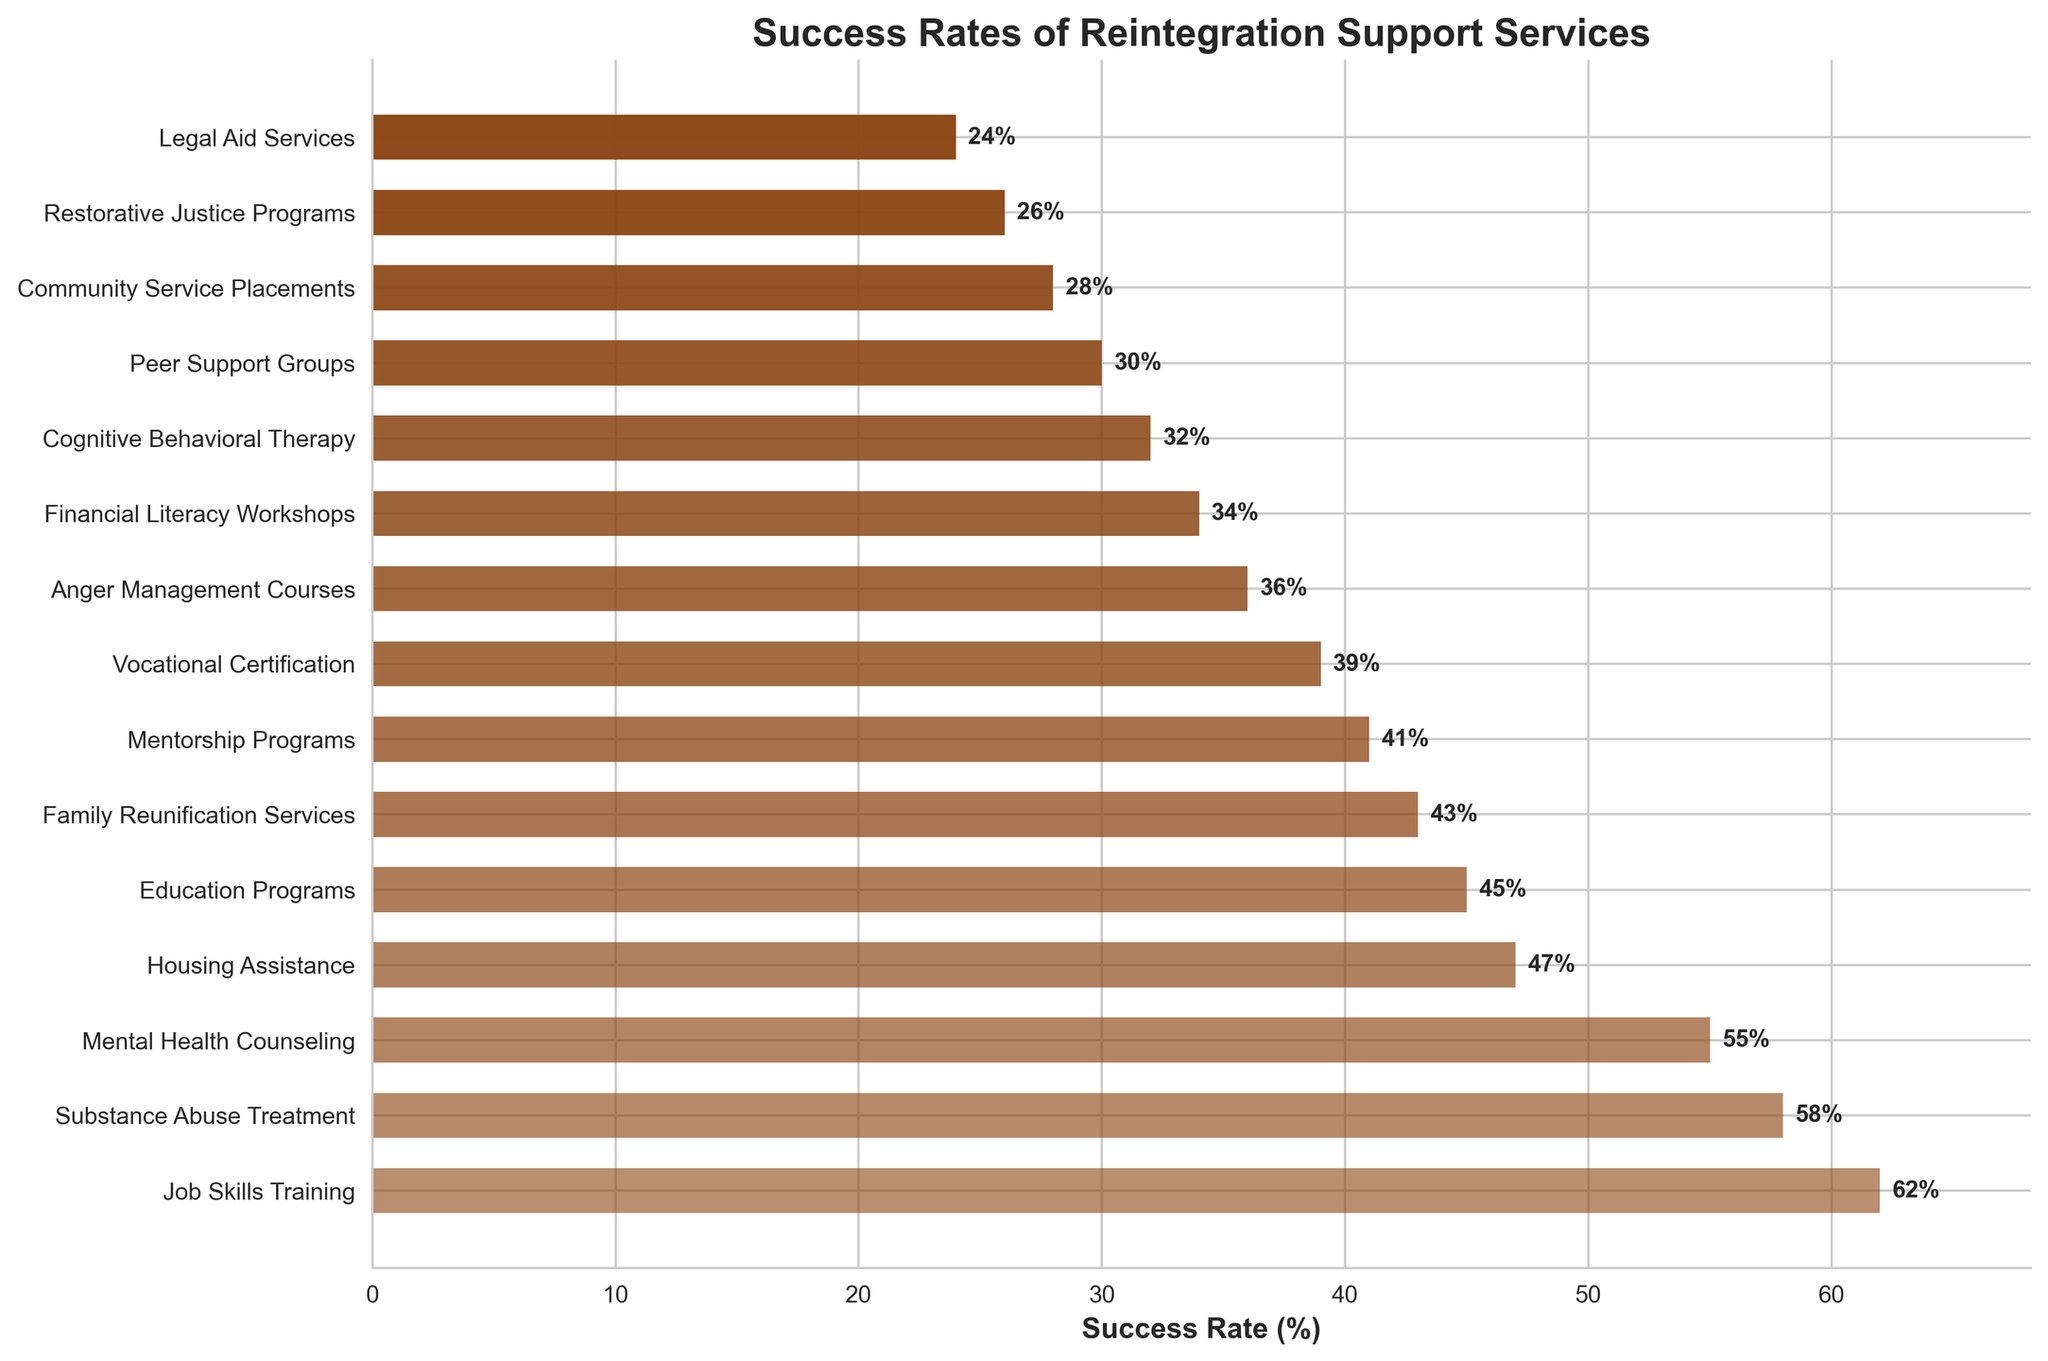Which reintegration support service has the highest success rate? To find the service with the highest success rate, look for the bar that is the longest in the plotted figure. The label associated with this bar represents the service with the highest success rate.
Answer: Job Skills Training Which reintegration support service has the lowest success rate? To identify the service with the lowest success rate, locate the shortest bar on the plot. The label next to this bar indicates the service with the lowest success rate.
Answer: Legal Aid Services How much higher is the success rate of 'Job Skills Training' compared to 'Financial Literacy Workshops'? Look at the bars corresponding to both 'Job Skills Training' and 'Financial Literacy Workshops'. The success rate for 'Job Skills Training' is 62%, and for 'Financial Literacy Workshops', it is 34%. Calculate the difference by subtracting 34% from 62%.
Answer: 28% What is the average success rate of the top five reintegration support services? Identify the top five services in terms of success rates: 'Job Skills Training' (62%), 'Substance Abuse Treatment' (58%), 'Mental Health Counseling' (55%), 'Housing Assistance' (47%), and 'Education Programs' (45%). Sum these rates and divide by 5. (62 + 58 + 55 + 47 + 45) / 5 = 267 / 5 = 53.4.
Answer: 53.4% How do the success rates of 'Peer Support Groups' and 'Restorative Justice Programs' compare? Compare the bar lengths for 'Peer Support Groups' and 'Restorative Justice Programs'. 'Peer Support Groups' has a success rate of 30%, and 'Restorative Justice Programs' has a rate of 26%. Hence, 'Peer Support Groups' has a slightly higher success rate.
Answer: Peer Support Groups Which support service has a success rate close to the median for all listed services? To find the median, order all the success rates and find the middle value. The ordered success rates are: 24, 26, 28, 30, 32, 34, 36, 39, 41, 43, 45, 47, 55, 58, 62. The median value, being the 8th in this ordered list, is 39%. The service with a 39% success rate is 'Vocational Certification'.
Answer: Vocational Certification 